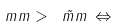<formula> <loc_0><loc_0><loc_500><loc_500>\ m m > \tilde { \ m m } \, \Leftrightarrow</formula> 